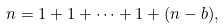Convert formula to latex. <formula><loc_0><loc_0><loc_500><loc_500>n = 1 + 1 + \cdots + 1 + ( n - b ) ,</formula> 